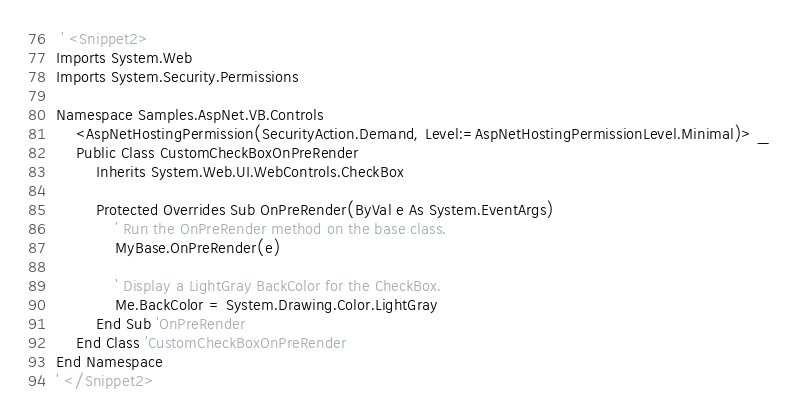<code> <loc_0><loc_0><loc_500><loc_500><_VisualBasic_> ' <Snippet2>
Imports System.Web
Imports System.Security.Permissions

Namespace Samples.AspNet.VB.Controls
    <AspNetHostingPermission(SecurityAction.Demand, Level:=AspNetHostingPermissionLevel.Minimal)> _
    Public Class CustomCheckBoxOnPreRender
        Inherits System.Web.UI.WebControls.CheckBox

        Protected Overrides Sub OnPreRender(ByVal e As System.EventArgs)
            ' Run the OnPreRender method on the base class.
            MyBase.OnPreRender(e)

            ' Display a LightGray BackColor for the CheckBox.
            Me.BackColor = System.Drawing.Color.LightGray
        End Sub 'OnPreRender
    End Class 'CustomCheckBoxOnPreRender
End Namespace
' </Snippet2></code> 